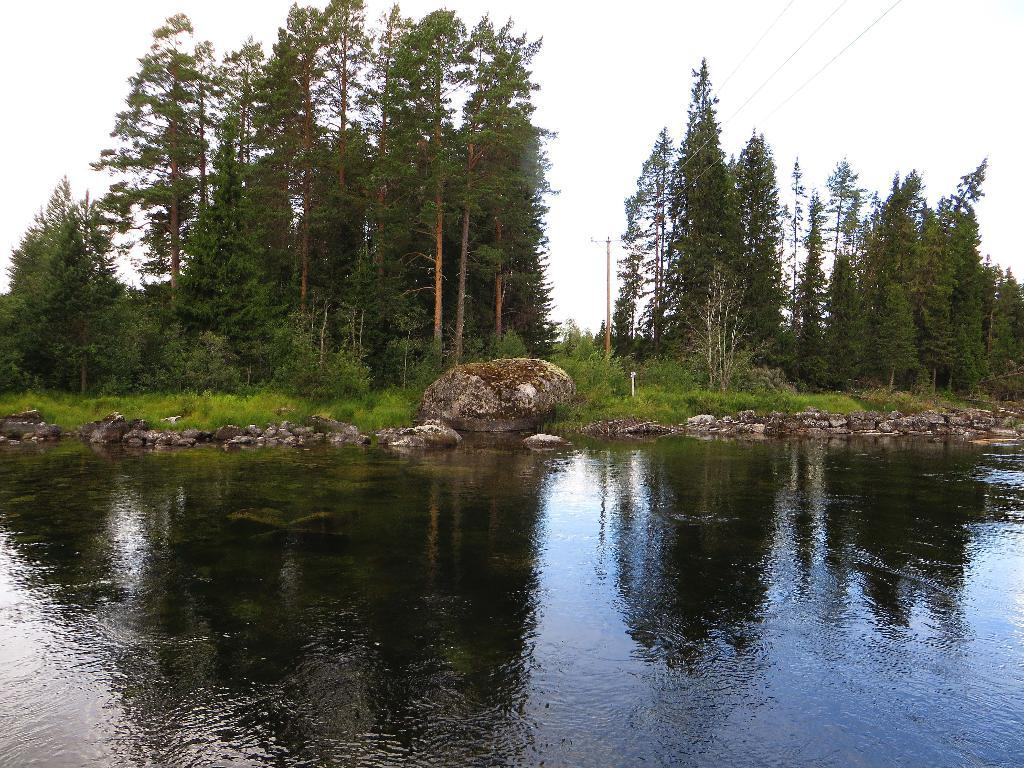What type of water is visible in the front of the image? There is lake water in the front of the image. What other objects can be seen in the image? There are stones and huge trees visible in the image. What is visible at the top of the image? The sky is visible at the top of the image. How much money is floating on the lake in the image? There is no money visible in the image; it only features lake water, stones, huge trees, and the sky. 